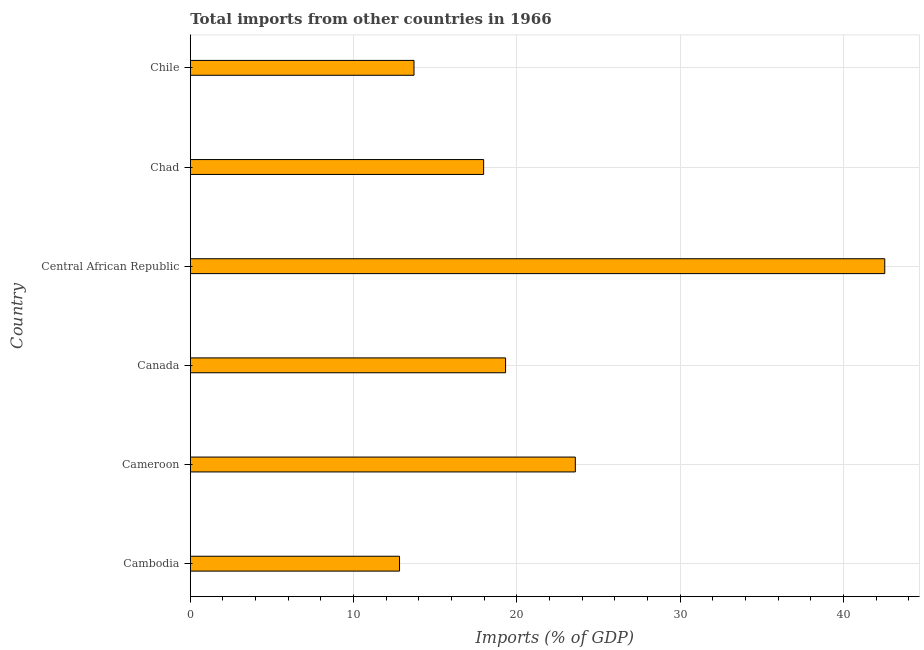Does the graph contain any zero values?
Your answer should be very brief. No. What is the title of the graph?
Keep it short and to the point. Total imports from other countries in 1966. What is the label or title of the X-axis?
Give a very brief answer. Imports (% of GDP). What is the total imports in Chad?
Make the answer very short. 17.96. Across all countries, what is the maximum total imports?
Your answer should be very brief. 42.53. Across all countries, what is the minimum total imports?
Provide a short and direct response. 12.81. In which country was the total imports maximum?
Make the answer very short. Central African Republic. In which country was the total imports minimum?
Make the answer very short. Cambodia. What is the sum of the total imports?
Your response must be concise. 129.88. What is the difference between the total imports in Central African Republic and Chad?
Make the answer very short. 24.56. What is the average total imports per country?
Ensure brevity in your answer.  21.65. What is the median total imports?
Ensure brevity in your answer.  18.63. What is the ratio of the total imports in Canada to that in Chile?
Make the answer very short. 1.41. Is the difference between the total imports in Cameroon and Chile greater than the difference between any two countries?
Ensure brevity in your answer.  No. What is the difference between the highest and the second highest total imports?
Your answer should be very brief. 18.95. What is the difference between the highest and the lowest total imports?
Offer a very short reply. 29.71. Are all the bars in the graph horizontal?
Ensure brevity in your answer.  Yes. What is the Imports (% of GDP) of Cambodia?
Provide a succinct answer. 12.81. What is the Imports (% of GDP) in Cameroon?
Ensure brevity in your answer.  23.58. What is the Imports (% of GDP) of Canada?
Provide a succinct answer. 19.31. What is the Imports (% of GDP) in Central African Republic?
Ensure brevity in your answer.  42.53. What is the Imports (% of GDP) in Chad?
Keep it short and to the point. 17.96. What is the Imports (% of GDP) of Chile?
Offer a very short reply. 13.7. What is the difference between the Imports (% of GDP) in Cambodia and Cameroon?
Ensure brevity in your answer.  -10.76. What is the difference between the Imports (% of GDP) in Cambodia and Canada?
Provide a succinct answer. -6.49. What is the difference between the Imports (% of GDP) in Cambodia and Central African Republic?
Your answer should be compact. -29.71. What is the difference between the Imports (% of GDP) in Cambodia and Chad?
Offer a terse response. -5.15. What is the difference between the Imports (% of GDP) in Cambodia and Chile?
Your answer should be very brief. -0.89. What is the difference between the Imports (% of GDP) in Cameroon and Canada?
Offer a very short reply. 4.27. What is the difference between the Imports (% of GDP) in Cameroon and Central African Republic?
Ensure brevity in your answer.  -18.95. What is the difference between the Imports (% of GDP) in Cameroon and Chad?
Provide a short and direct response. 5.61. What is the difference between the Imports (% of GDP) in Cameroon and Chile?
Offer a very short reply. 9.88. What is the difference between the Imports (% of GDP) in Canada and Central African Republic?
Your answer should be very brief. -23.22. What is the difference between the Imports (% of GDP) in Canada and Chad?
Your answer should be compact. 1.34. What is the difference between the Imports (% of GDP) in Canada and Chile?
Ensure brevity in your answer.  5.61. What is the difference between the Imports (% of GDP) in Central African Republic and Chad?
Offer a terse response. 24.56. What is the difference between the Imports (% of GDP) in Central African Republic and Chile?
Provide a succinct answer. 28.83. What is the difference between the Imports (% of GDP) in Chad and Chile?
Your answer should be compact. 4.26. What is the ratio of the Imports (% of GDP) in Cambodia to that in Cameroon?
Provide a short and direct response. 0.54. What is the ratio of the Imports (% of GDP) in Cambodia to that in Canada?
Your answer should be very brief. 0.66. What is the ratio of the Imports (% of GDP) in Cambodia to that in Central African Republic?
Provide a succinct answer. 0.3. What is the ratio of the Imports (% of GDP) in Cambodia to that in Chad?
Make the answer very short. 0.71. What is the ratio of the Imports (% of GDP) in Cambodia to that in Chile?
Give a very brief answer. 0.94. What is the ratio of the Imports (% of GDP) in Cameroon to that in Canada?
Your answer should be very brief. 1.22. What is the ratio of the Imports (% of GDP) in Cameroon to that in Central African Republic?
Give a very brief answer. 0.55. What is the ratio of the Imports (% of GDP) in Cameroon to that in Chad?
Offer a very short reply. 1.31. What is the ratio of the Imports (% of GDP) in Cameroon to that in Chile?
Offer a terse response. 1.72. What is the ratio of the Imports (% of GDP) in Canada to that in Central African Republic?
Your answer should be compact. 0.45. What is the ratio of the Imports (% of GDP) in Canada to that in Chad?
Your response must be concise. 1.07. What is the ratio of the Imports (% of GDP) in Canada to that in Chile?
Offer a very short reply. 1.41. What is the ratio of the Imports (% of GDP) in Central African Republic to that in Chad?
Ensure brevity in your answer.  2.37. What is the ratio of the Imports (% of GDP) in Central African Republic to that in Chile?
Make the answer very short. 3.1. What is the ratio of the Imports (% of GDP) in Chad to that in Chile?
Provide a short and direct response. 1.31. 